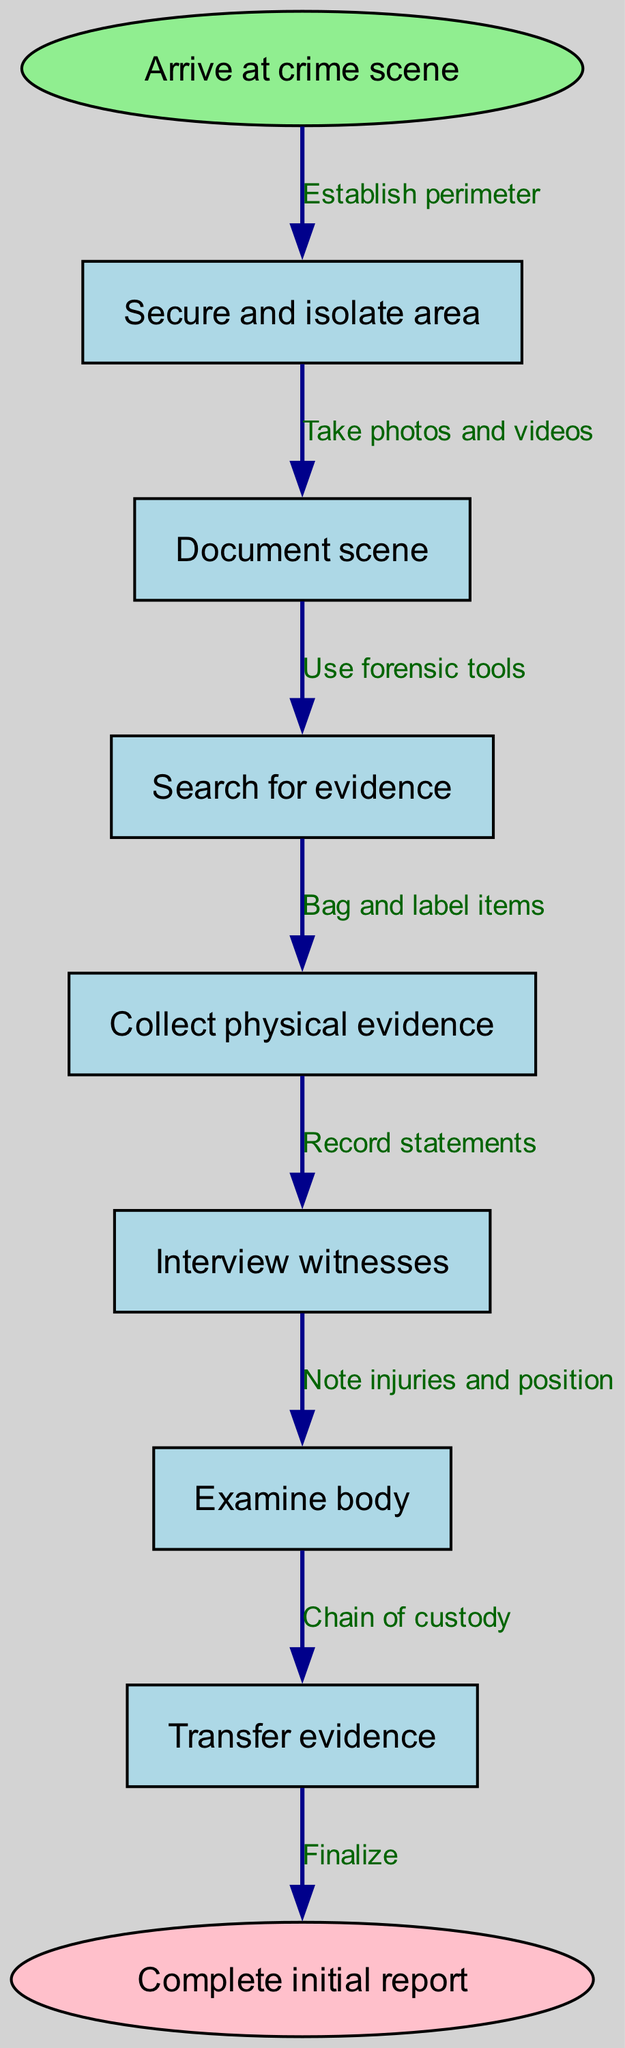What is the first step in the protocol? The first step, indicated at the top of the flow chart, is where the process begins, labeled as "Arrive at crime scene."
Answer: Arrive at crime scene How many steps are in the protocol? By counting all the nodes listed between the start and end nodes, we find there are a total of 6 steps in the protocol.
Answer: 6 What is the relationship between securing the area and documenting the scene? The flow chart shows that the first step is to secure and isolate the area, which is immediately followed by documenting the scene, indicating a direct sequence of actions.
Answer: Establish perimeter What is the last action before completing the initial report? The last step before reaching the end node labeled "Complete initial report" is transferring evidence, which ensures all collected materials are properly accounted for.
Answer: Chain of custody In which step are physical evidence collected? The collection of physical evidence is specifically mentioned as its own step, referred to as "Collect physical evidence."
Answer: Bag and label items What step follows the examination of the body? According to the flowchart, after examining the body, the next logical step involves interviewing witnesses, highlighting the link between physical evidence and witness statements.
Answer: Record statements What do you do after searching for evidence? The flow chart indicates that after searching for evidence, the next step is to collect the physical evidence that has been identified during the search, furthering the investigative process.
Answer: Bag and label items What is the second action in the protocol? The second action, derived from the flow of the diagram, is to document the scene, which follows the establishment of the perimeter.
Answer: Take photos and videos How does the protocol ensure the integrity of evidence? The diagram establishes a chain of custody after collecting physical evidence, indicating a formal procedure to ensure that evidence is handled and stored correctly to maintain its integrity.
Answer: Chain of custody 